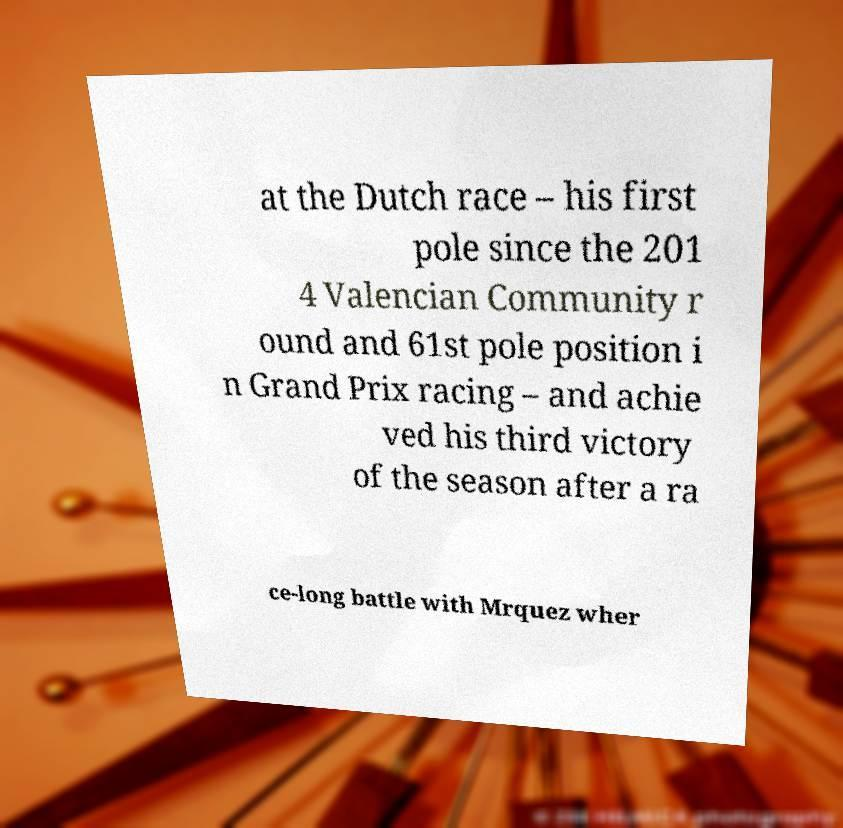Could you assist in decoding the text presented in this image and type it out clearly? at the Dutch race – his first pole since the 201 4 Valencian Community r ound and 61st pole position i n Grand Prix racing – and achie ved his third victory of the season after a ra ce-long battle with Mrquez wher 